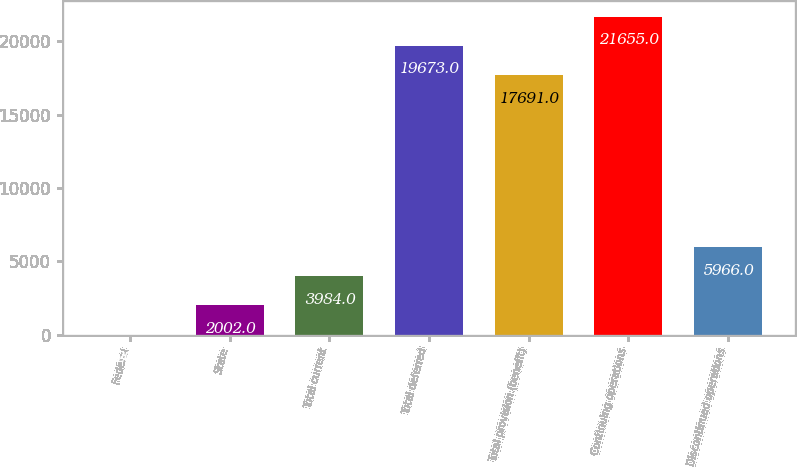<chart> <loc_0><loc_0><loc_500><loc_500><bar_chart><fcel>Federal<fcel>State<fcel>Total current<fcel>Total deferred<fcel>Total provision (benefit)<fcel>Continuing operations<fcel>Discontinued operations<nl><fcel>20<fcel>2002<fcel>3984<fcel>19673<fcel>17691<fcel>21655<fcel>5966<nl></chart> 